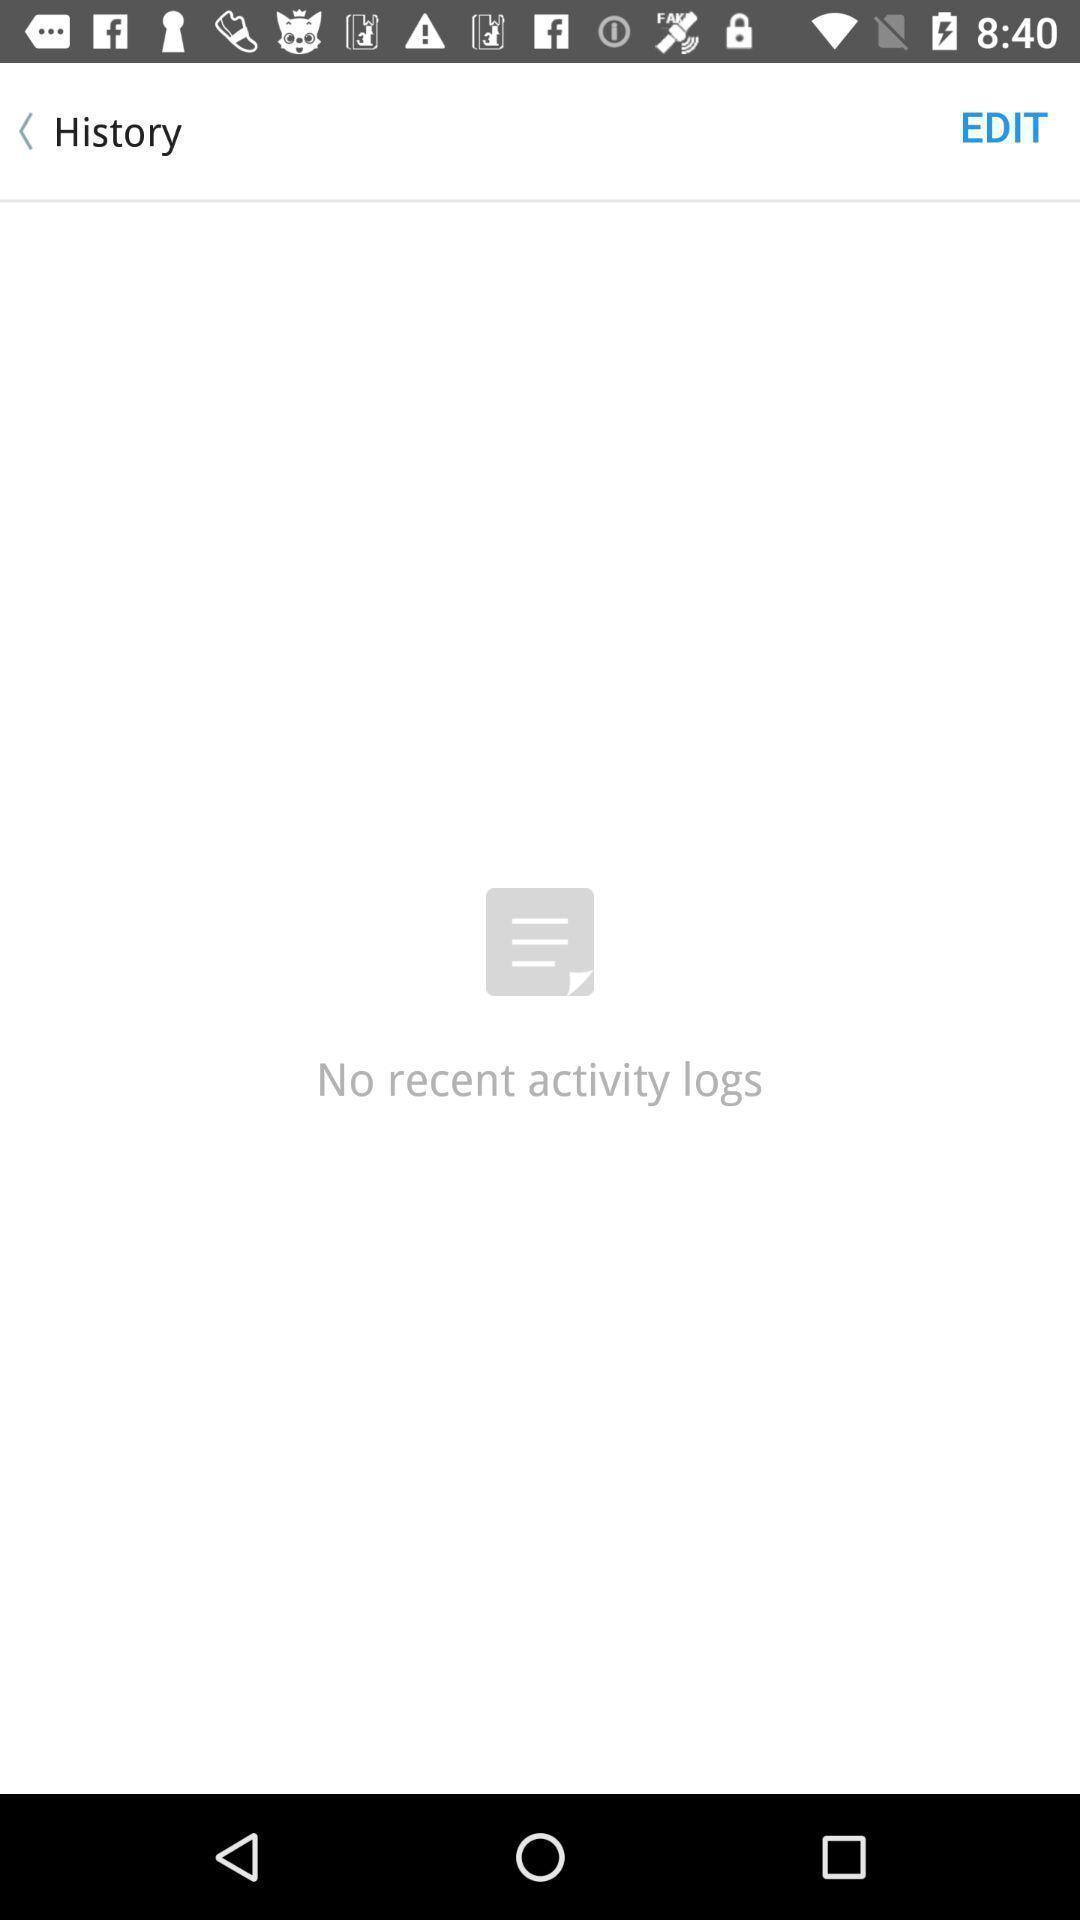Provide a textual representation of this image. Screen shows history page. 